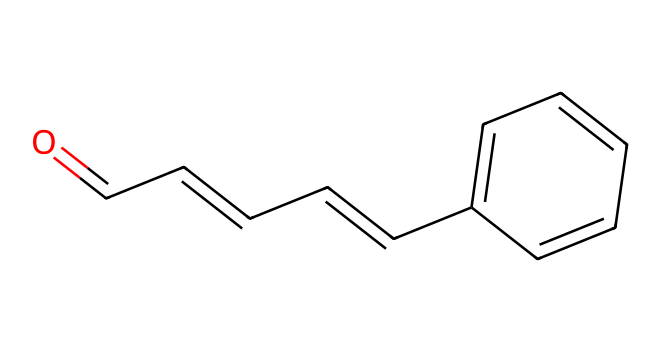How many carbon atoms are in cinnamaldehyde? Counting the carbon atoms in the SMILES representation, we see that there are nine carbon atoms present, directly observable from the structure.
Answer: nine What is the functional group present in cinnamaldehyde? The SMILES notation shows a carbon atom involved in a double bond with oxygen (O=), which indicates the presence of an aldehyde functional group.
Answer: aldehyde How many double bonds are present in this compound? By examining the structure, we can identify two double bonds; one at the carbonyl and another within the carbon chain.
Answer: two What is the molecular formula of cinnamaldehyde? Based on the carbon (9), hydrogen (8), and oxygen (1) atoms counted in the SMILES, the molecular formula can be derived as C9H8O.
Answer: C9H8O Which part of the structure contributes to its aromatic properties? The benzene ring (C1=CC=CC=C1) in the structure showcases delocalized electrons, indicating its aromatic character.
Answer: benzene ring Why does cinnamaldehyde have a distinctive scent? The presence of the aldehyde functional group combined with the aromatic ring influences the volatility and the specific olfactory characteristics contributing to its distinctive scent.
Answer: aromatic ring and aldehyde How many hydrogen atoms are attached to the carbon skeleton? In the carbon skeleton, after considering the bonding patterns, we observe a total of eight hydrogen atoms directly connected to the carbon atoms within the structure.
Answer: eight 